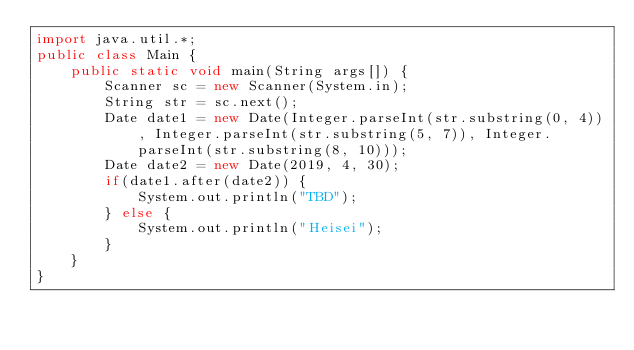Convert code to text. <code><loc_0><loc_0><loc_500><loc_500><_Java_>import java.util.*;
public class Main {
	public static void main(String args[]) {
		Scanner sc = new Scanner(System.in);
		String str = sc.next();
		Date date1 = new Date(Integer.parseInt(str.substring(0, 4)), Integer.parseInt(str.substring(5, 7)), Integer.parseInt(str.substring(8, 10)));
		Date date2 = new Date(2019, 4, 30);
		if(date1.after(date2)) {
			System.out.println("TBD");
		} else {
			System.out.println("Heisei");
		}
	}
}
</code> 